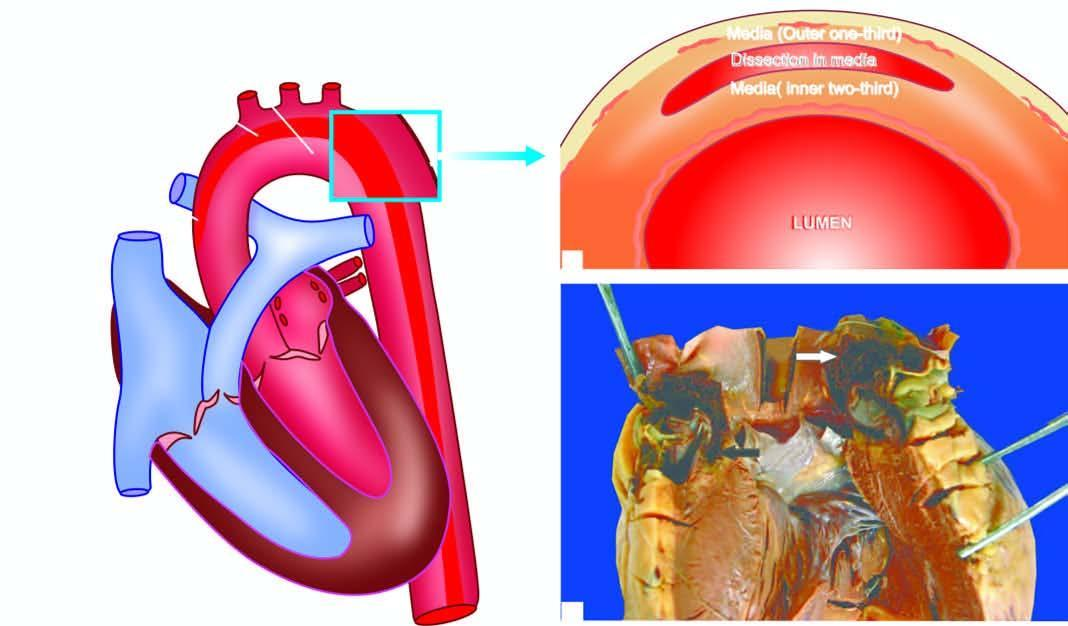what is the ascending aorta seen with?
Answer the question using a single word or phrase. The heart 